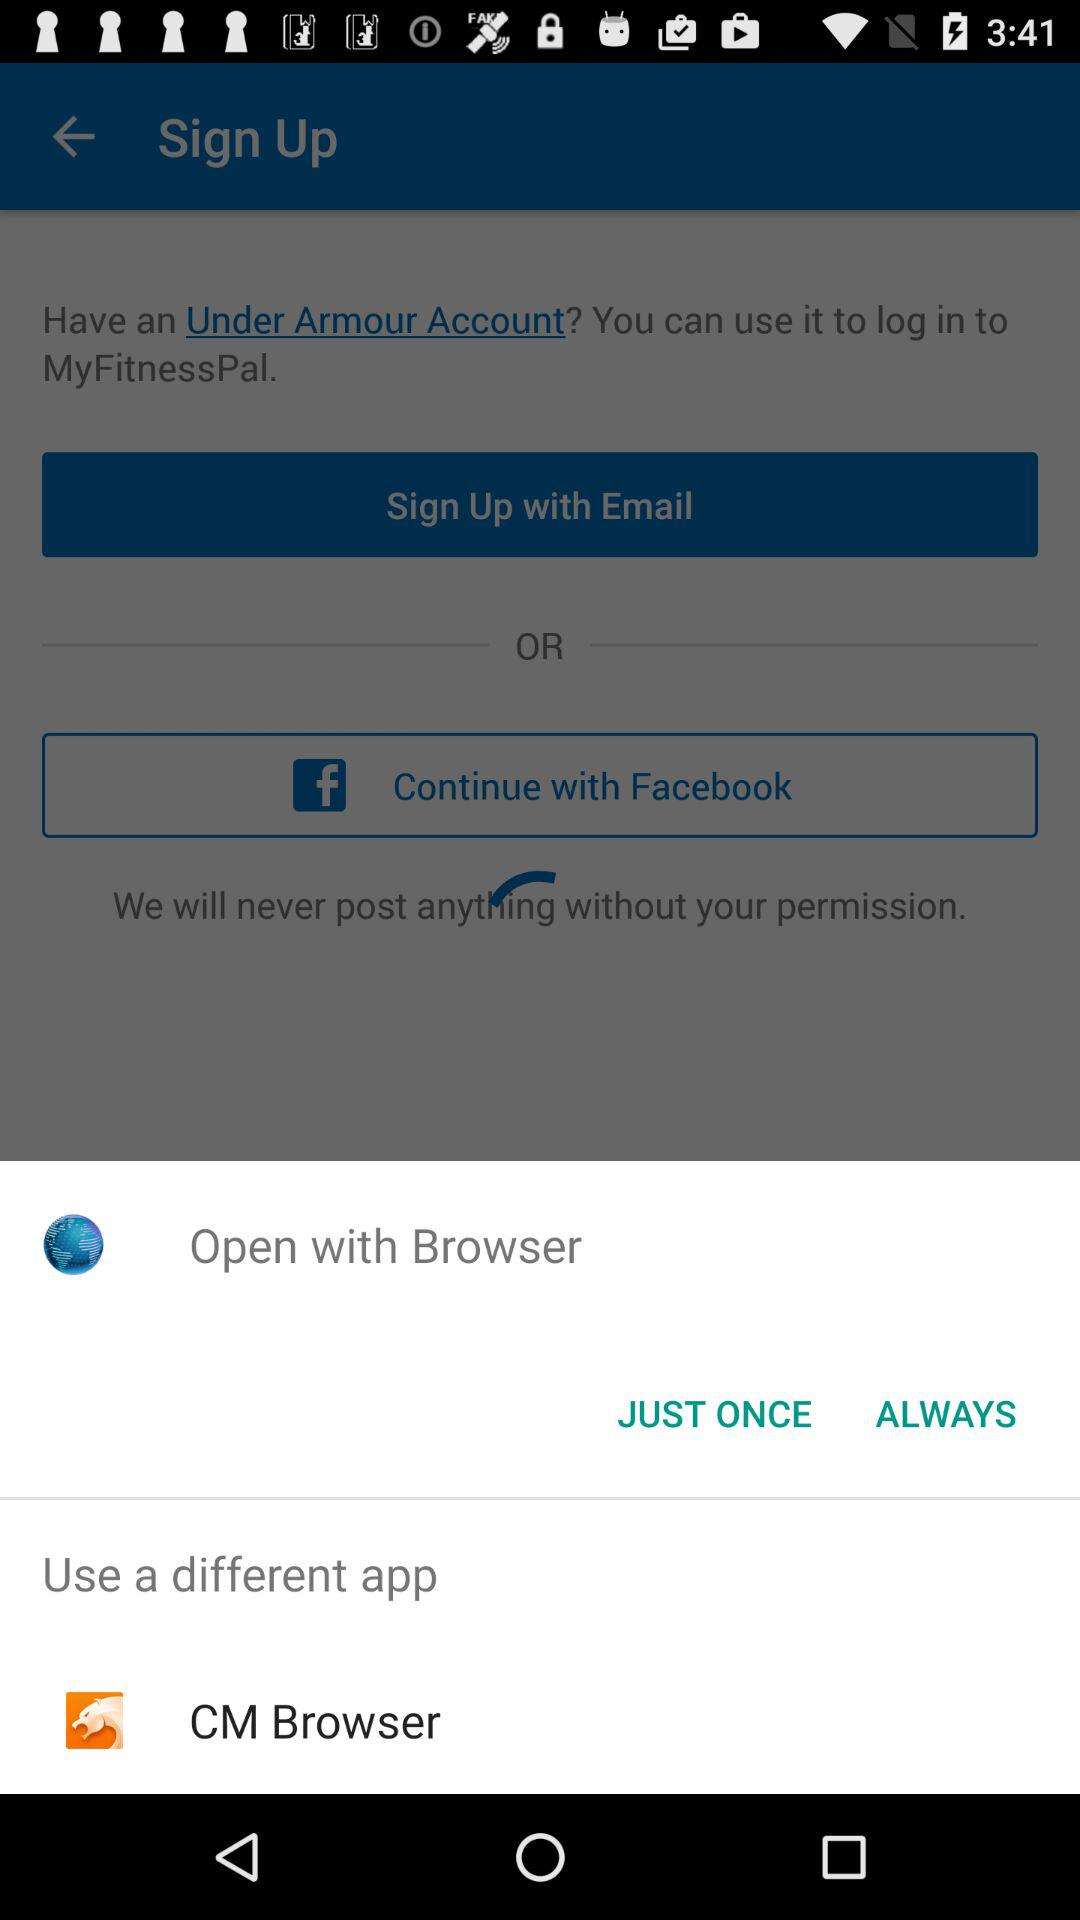How many social media options are there?
Answer the question using a single word or phrase. 2 